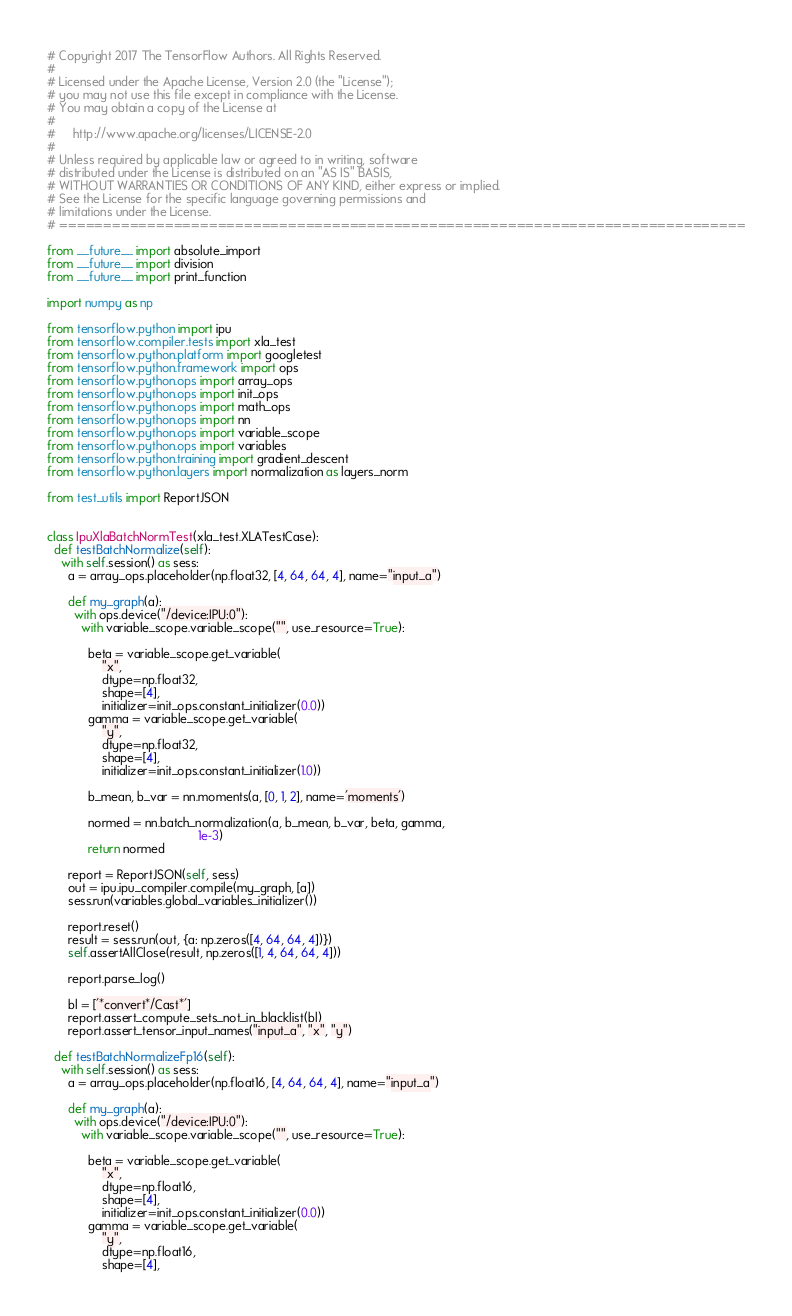<code> <loc_0><loc_0><loc_500><loc_500><_Python_># Copyright 2017 The TensorFlow Authors. All Rights Reserved.
#
# Licensed under the Apache License, Version 2.0 (the "License");
# you may not use this file except in compliance with the License.
# You may obtain a copy of the License at
#
#     http://www.apache.org/licenses/LICENSE-2.0
#
# Unless required by applicable law or agreed to in writing, software
# distributed under the License is distributed on an "AS IS" BASIS,
# WITHOUT WARRANTIES OR CONDITIONS OF ANY KIND, either express or implied.
# See the License for the specific language governing permissions and
# limitations under the License.
# ==============================================================================

from __future__ import absolute_import
from __future__ import division
from __future__ import print_function

import numpy as np

from tensorflow.python import ipu
from tensorflow.compiler.tests import xla_test
from tensorflow.python.platform import googletest
from tensorflow.python.framework import ops
from tensorflow.python.ops import array_ops
from tensorflow.python.ops import init_ops
from tensorflow.python.ops import math_ops
from tensorflow.python.ops import nn
from tensorflow.python.ops import variable_scope
from tensorflow.python.ops import variables
from tensorflow.python.training import gradient_descent
from tensorflow.python.layers import normalization as layers_norm

from test_utils import ReportJSON


class IpuXlaBatchNormTest(xla_test.XLATestCase):
  def testBatchNormalize(self):
    with self.session() as sess:
      a = array_ops.placeholder(np.float32, [4, 64, 64, 4], name="input_a")

      def my_graph(a):
        with ops.device("/device:IPU:0"):
          with variable_scope.variable_scope("", use_resource=True):

            beta = variable_scope.get_variable(
                "x",
                dtype=np.float32,
                shape=[4],
                initializer=init_ops.constant_initializer(0.0))
            gamma = variable_scope.get_variable(
                "y",
                dtype=np.float32,
                shape=[4],
                initializer=init_ops.constant_initializer(1.0))

            b_mean, b_var = nn.moments(a, [0, 1, 2], name='moments')

            normed = nn.batch_normalization(a, b_mean, b_var, beta, gamma,
                                            1e-3)
            return normed

      report = ReportJSON(self, sess)
      out = ipu.ipu_compiler.compile(my_graph, [a])
      sess.run(variables.global_variables_initializer())

      report.reset()
      result = sess.run(out, {a: np.zeros([4, 64, 64, 4])})
      self.assertAllClose(result, np.zeros([1, 4, 64, 64, 4]))

      report.parse_log()

      bl = ['*convert*/Cast*']
      report.assert_compute_sets_not_in_blacklist(bl)
      report.assert_tensor_input_names("input_a", "x", "y")

  def testBatchNormalizeFp16(self):
    with self.session() as sess:
      a = array_ops.placeholder(np.float16, [4, 64, 64, 4], name="input_a")

      def my_graph(a):
        with ops.device("/device:IPU:0"):
          with variable_scope.variable_scope("", use_resource=True):

            beta = variable_scope.get_variable(
                "x",
                dtype=np.float16,
                shape=[4],
                initializer=init_ops.constant_initializer(0.0))
            gamma = variable_scope.get_variable(
                "y",
                dtype=np.float16,
                shape=[4],</code> 